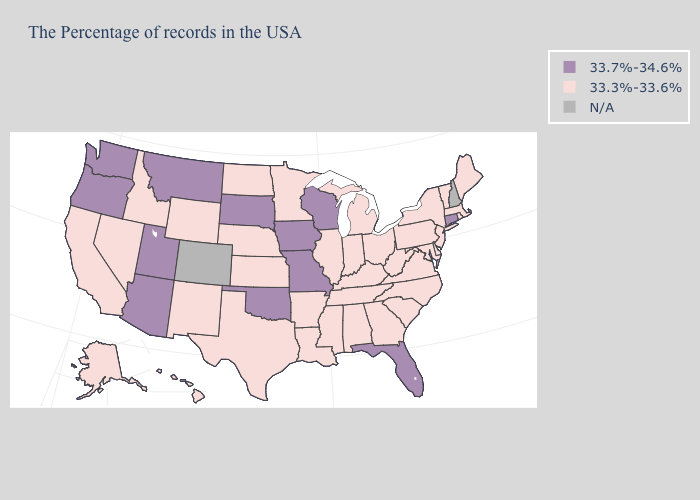Name the states that have a value in the range 33.3%-33.6%?
Short answer required. Maine, Massachusetts, Rhode Island, Vermont, New York, New Jersey, Delaware, Maryland, Pennsylvania, Virginia, North Carolina, South Carolina, West Virginia, Ohio, Georgia, Michigan, Kentucky, Indiana, Alabama, Tennessee, Illinois, Mississippi, Louisiana, Arkansas, Minnesota, Kansas, Nebraska, Texas, North Dakota, Wyoming, New Mexico, Idaho, Nevada, California, Alaska, Hawaii. Name the states that have a value in the range 33.7%-34.6%?
Quick response, please. Connecticut, Florida, Wisconsin, Missouri, Iowa, Oklahoma, South Dakota, Utah, Montana, Arizona, Washington, Oregon. How many symbols are there in the legend?
Concise answer only. 3. What is the value of Hawaii?
Short answer required. 33.3%-33.6%. What is the value of Massachusetts?
Give a very brief answer. 33.3%-33.6%. What is the lowest value in states that border Indiana?
Give a very brief answer. 33.3%-33.6%. Name the states that have a value in the range N/A?
Keep it brief. New Hampshire, Colorado. Is the legend a continuous bar?
Write a very short answer. No. Which states hav the highest value in the South?
Short answer required. Florida, Oklahoma. How many symbols are there in the legend?
Concise answer only. 3. Name the states that have a value in the range N/A?
Be succinct. New Hampshire, Colorado. 